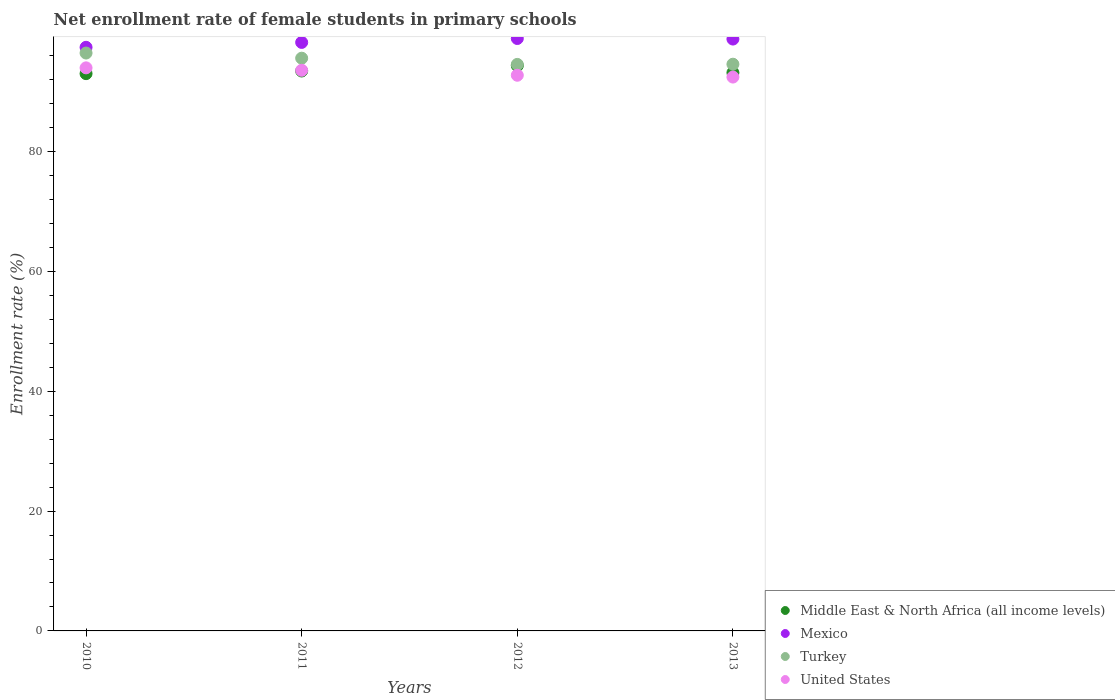What is the net enrollment rate of female students in primary schools in Mexico in 2012?
Offer a terse response. 98.86. Across all years, what is the maximum net enrollment rate of female students in primary schools in Mexico?
Keep it short and to the point. 98.86. Across all years, what is the minimum net enrollment rate of female students in primary schools in Mexico?
Offer a terse response. 97.39. What is the total net enrollment rate of female students in primary schools in United States in the graph?
Make the answer very short. 372.65. What is the difference between the net enrollment rate of female students in primary schools in Turkey in 2010 and that in 2013?
Give a very brief answer. 1.86. What is the difference between the net enrollment rate of female students in primary schools in United States in 2011 and the net enrollment rate of female students in primary schools in Middle East & North Africa (all income levels) in 2013?
Provide a succinct answer. 0.4. What is the average net enrollment rate of female students in primary schools in Turkey per year?
Your response must be concise. 95.27. In the year 2010, what is the difference between the net enrollment rate of female students in primary schools in Turkey and net enrollment rate of female students in primary schools in Middle East & North Africa (all income levels)?
Provide a short and direct response. 3.44. What is the ratio of the net enrollment rate of female students in primary schools in Turkey in 2011 to that in 2013?
Keep it short and to the point. 1.01. Is the net enrollment rate of female students in primary schools in Turkey in 2010 less than that in 2011?
Offer a very short reply. No. What is the difference between the highest and the second highest net enrollment rate of female students in primary schools in Turkey?
Your answer should be compact. 0.86. What is the difference between the highest and the lowest net enrollment rate of female students in primary schools in Turkey?
Offer a very short reply. 1.9. In how many years, is the net enrollment rate of female students in primary schools in Mexico greater than the average net enrollment rate of female students in primary schools in Mexico taken over all years?
Your answer should be compact. 2. Is it the case that in every year, the sum of the net enrollment rate of female students in primary schools in United States and net enrollment rate of female students in primary schools in Turkey  is greater than the sum of net enrollment rate of female students in primary schools in Mexico and net enrollment rate of female students in primary schools in Middle East & North Africa (all income levels)?
Keep it short and to the point. No. Does the net enrollment rate of female students in primary schools in United States monotonically increase over the years?
Ensure brevity in your answer.  No. Is the net enrollment rate of female students in primary schools in Turkey strictly greater than the net enrollment rate of female students in primary schools in United States over the years?
Keep it short and to the point. Yes. Is the net enrollment rate of female students in primary schools in United States strictly less than the net enrollment rate of female students in primary schools in Turkey over the years?
Your answer should be very brief. Yes. What is the title of the graph?
Ensure brevity in your answer.  Net enrollment rate of female students in primary schools. Does "Chile" appear as one of the legend labels in the graph?
Keep it short and to the point. No. What is the label or title of the Y-axis?
Make the answer very short. Enrollment rate (%). What is the Enrollment rate (%) of Middle East & North Africa (all income levels) in 2010?
Your answer should be very brief. 92.99. What is the Enrollment rate (%) of Mexico in 2010?
Provide a short and direct response. 97.39. What is the Enrollment rate (%) of Turkey in 2010?
Your answer should be compact. 96.43. What is the Enrollment rate (%) in United States in 2010?
Provide a succinct answer. 93.96. What is the Enrollment rate (%) in Middle East & North Africa (all income levels) in 2011?
Make the answer very short. 93.43. What is the Enrollment rate (%) in Mexico in 2011?
Your response must be concise. 98.2. What is the Enrollment rate (%) of Turkey in 2011?
Your answer should be compact. 95.57. What is the Enrollment rate (%) of United States in 2011?
Provide a succinct answer. 93.55. What is the Enrollment rate (%) in Middle East & North Africa (all income levels) in 2012?
Keep it short and to the point. 94.33. What is the Enrollment rate (%) in Mexico in 2012?
Make the answer very short. 98.86. What is the Enrollment rate (%) in Turkey in 2012?
Ensure brevity in your answer.  94.53. What is the Enrollment rate (%) of United States in 2012?
Your answer should be compact. 92.72. What is the Enrollment rate (%) of Middle East & North Africa (all income levels) in 2013?
Ensure brevity in your answer.  93.15. What is the Enrollment rate (%) in Mexico in 2013?
Your answer should be compact. 98.76. What is the Enrollment rate (%) of Turkey in 2013?
Offer a very short reply. 94.57. What is the Enrollment rate (%) in United States in 2013?
Give a very brief answer. 92.42. Across all years, what is the maximum Enrollment rate (%) of Middle East & North Africa (all income levels)?
Your response must be concise. 94.33. Across all years, what is the maximum Enrollment rate (%) in Mexico?
Provide a succinct answer. 98.86. Across all years, what is the maximum Enrollment rate (%) in Turkey?
Provide a short and direct response. 96.43. Across all years, what is the maximum Enrollment rate (%) in United States?
Your answer should be compact. 93.96. Across all years, what is the minimum Enrollment rate (%) of Middle East & North Africa (all income levels)?
Your response must be concise. 92.99. Across all years, what is the minimum Enrollment rate (%) of Mexico?
Offer a terse response. 97.39. Across all years, what is the minimum Enrollment rate (%) in Turkey?
Your response must be concise. 94.53. Across all years, what is the minimum Enrollment rate (%) in United States?
Provide a short and direct response. 92.42. What is the total Enrollment rate (%) of Middle East & North Africa (all income levels) in the graph?
Provide a succinct answer. 373.9. What is the total Enrollment rate (%) in Mexico in the graph?
Offer a terse response. 393.2. What is the total Enrollment rate (%) of Turkey in the graph?
Give a very brief answer. 381.1. What is the total Enrollment rate (%) in United States in the graph?
Your answer should be very brief. 372.65. What is the difference between the Enrollment rate (%) of Middle East & North Africa (all income levels) in 2010 and that in 2011?
Make the answer very short. -0.44. What is the difference between the Enrollment rate (%) in Mexico in 2010 and that in 2011?
Your answer should be very brief. -0.82. What is the difference between the Enrollment rate (%) of Turkey in 2010 and that in 2011?
Give a very brief answer. 0.86. What is the difference between the Enrollment rate (%) of United States in 2010 and that in 2011?
Ensure brevity in your answer.  0.41. What is the difference between the Enrollment rate (%) in Middle East & North Africa (all income levels) in 2010 and that in 2012?
Provide a succinct answer. -1.34. What is the difference between the Enrollment rate (%) of Mexico in 2010 and that in 2012?
Give a very brief answer. -1.47. What is the difference between the Enrollment rate (%) in Turkey in 2010 and that in 2012?
Your response must be concise. 1.9. What is the difference between the Enrollment rate (%) of United States in 2010 and that in 2012?
Ensure brevity in your answer.  1.24. What is the difference between the Enrollment rate (%) of Middle East & North Africa (all income levels) in 2010 and that in 2013?
Your response must be concise. -0.16. What is the difference between the Enrollment rate (%) in Mexico in 2010 and that in 2013?
Keep it short and to the point. -1.38. What is the difference between the Enrollment rate (%) of Turkey in 2010 and that in 2013?
Keep it short and to the point. 1.86. What is the difference between the Enrollment rate (%) of United States in 2010 and that in 2013?
Give a very brief answer. 1.54. What is the difference between the Enrollment rate (%) of Middle East & North Africa (all income levels) in 2011 and that in 2012?
Your response must be concise. -0.9. What is the difference between the Enrollment rate (%) of Mexico in 2011 and that in 2012?
Your response must be concise. -0.65. What is the difference between the Enrollment rate (%) in Turkey in 2011 and that in 2012?
Ensure brevity in your answer.  1.04. What is the difference between the Enrollment rate (%) of United States in 2011 and that in 2012?
Your answer should be compact. 0.83. What is the difference between the Enrollment rate (%) in Middle East & North Africa (all income levels) in 2011 and that in 2013?
Give a very brief answer. 0.28. What is the difference between the Enrollment rate (%) in Mexico in 2011 and that in 2013?
Provide a short and direct response. -0.56. What is the difference between the Enrollment rate (%) of United States in 2011 and that in 2013?
Give a very brief answer. 1.13. What is the difference between the Enrollment rate (%) in Middle East & North Africa (all income levels) in 2012 and that in 2013?
Offer a very short reply. 1.18. What is the difference between the Enrollment rate (%) in Mexico in 2012 and that in 2013?
Your answer should be very brief. 0.09. What is the difference between the Enrollment rate (%) in Turkey in 2012 and that in 2013?
Your response must be concise. -0.03. What is the difference between the Enrollment rate (%) of United States in 2012 and that in 2013?
Provide a succinct answer. 0.3. What is the difference between the Enrollment rate (%) in Middle East & North Africa (all income levels) in 2010 and the Enrollment rate (%) in Mexico in 2011?
Offer a terse response. -5.21. What is the difference between the Enrollment rate (%) of Middle East & North Africa (all income levels) in 2010 and the Enrollment rate (%) of Turkey in 2011?
Ensure brevity in your answer.  -2.58. What is the difference between the Enrollment rate (%) in Middle East & North Africa (all income levels) in 2010 and the Enrollment rate (%) in United States in 2011?
Offer a very short reply. -0.56. What is the difference between the Enrollment rate (%) in Mexico in 2010 and the Enrollment rate (%) in Turkey in 2011?
Your response must be concise. 1.82. What is the difference between the Enrollment rate (%) in Mexico in 2010 and the Enrollment rate (%) in United States in 2011?
Keep it short and to the point. 3.84. What is the difference between the Enrollment rate (%) in Turkey in 2010 and the Enrollment rate (%) in United States in 2011?
Provide a short and direct response. 2.88. What is the difference between the Enrollment rate (%) in Middle East & North Africa (all income levels) in 2010 and the Enrollment rate (%) in Mexico in 2012?
Your response must be concise. -5.86. What is the difference between the Enrollment rate (%) of Middle East & North Africa (all income levels) in 2010 and the Enrollment rate (%) of Turkey in 2012?
Ensure brevity in your answer.  -1.54. What is the difference between the Enrollment rate (%) in Middle East & North Africa (all income levels) in 2010 and the Enrollment rate (%) in United States in 2012?
Provide a short and direct response. 0.27. What is the difference between the Enrollment rate (%) of Mexico in 2010 and the Enrollment rate (%) of Turkey in 2012?
Offer a terse response. 2.85. What is the difference between the Enrollment rate (%) of Mexico in 2010 and the Enrollment rate (%) of United States in 2012?
Your answer should be compact. 4.66. What is the difference between the Enrollment rate (%) in Turkey in 2010 and the Enrollment rate (%) in United States in 2012?
Your answer should be very brief. 3.71. What is the difference between the Enrollment rate (%) in Middle East & North Africa (all income levels) in 2010 and the Enrollment rate (%) in Mexico in 2013?
Your response must be concise. -5.77. What is the difference between the Enrollment rate (%) in Middle East & North Africa (all income levels) in 2010 and the Enrollment rate (%) in Turkey in 2013?
Provide a short and direct response. -1.58. What is the difference between the Enrollment rate (%) of Middle East & North Africa (all income levels) in 2010 and the Enrollment rate (%) of United States in 2013?
Give a very brief answer. 0.57. What is the difference between the Enrollment rate (%) in Mexico in 2010 and the Enrollment rate (%) in Turkey in 2013?
Provide a succinct answer. 2.82. What is the difference between the Enrollment rate (%) in Mexico in 2010 and the Enrollment rate (%) in United States in 2013?
Offer a very short reply. 4.97. What is the difference between the Enrollment rate (%) in Turkey in 2010 and the Enrollment rate (%) in United States in 2013?
Make the answer very short. 4.01. What is the difference between the Enrollment rate (%) of Middle East & North Africa (all income levels) in 2011 and the Enrollment rate (%) of Mexico in 2012?
Your answer should be very brief. -5.43. What is the difference between the Enrollment rate (%) of Middle East & North Africa (all income levels) in 2011 and the Enrollment rate (%) of Turkey in 2012?
Your response must be concise. -1.1. What is the difference between the Enrollment rate (%) in Middle East & North Africa (all income levels) in 2011 and the Enrollment rate (%) in United States in 2012?
Ensure brevity in your answer.  0.71. What is the difference between the Enrollment rate (%) of Mexico in 2011 and the Enrollment rate (%) of Turkey in 2012?
Provide a short and direct response. 3.67. What is the difference between the Enrollment rate (%) in Mexico in 2011 and the Enrollment rate (%) in United States in 2012?
Make the answer very short. 5.48. What is the difference between the Enrollment rate (%) of Turkey in 2011 and the Enrollment rate (%) of United States in 2012?
Keep it short and to the point. 2.85. What is the difference between the Enrollment rate (%) of Middle East & North Africa (all income levels) in 2011 and the Enrollment rate (%) of Mexico in 2013?
Your answer should be very brief. -5.33. What is the difference between the Enrollment rate (%) of Middle East & North Africa (all income levels) in 2011 and the Enrollment rate (%) of Turkey in 2013?
Your response must be concise. -1.14. What is the difference between the Enrollment rate (%) in Middle East & North Africa (all income levels) in 2011 and the Enrollment rate (%) in United States in 2013?
Your response must be concise. 1.01. What is the difference between the Enrollment rate (%) of Mexico in 2011 and the Enrollment rate (%) of Turkey in 2013?
Offer a very short reply. 3.64. What is the difference between the Enrollment rate (%) in Mexico in 2011 and the Enrollment rate (%) in United States in 2013?
Your answer should be very brief. 5.78. What is the difference between the Enrollment rate (%) in Turkey in 2011 and the Enrollment rate (%) in United States in 2013?
Offer a very short reply. 3.15. What is the difference between the Enrollment rate (%) of Middle East & North Africa (all income levels) in 2012 and the Enrollment rate (%) of Mexico in 2013?
Offer a very short reply. -4.43. What is the difference between the Enrollment rate (%) in Middle East & North Africa (all income levels) in 2012 and the Enrollment rate (%) in Turkey in 2013?
Keep it short and to the point. -0.24. What is the difference between the Enrollment rate (%) in Middle East & North Africa (all income levels) in 2012 and the Enrollment rate (%) in United States in 2013?
Provide a short and direct response. 1.91. What is the difference between the Enrollment rate (%) of Mexico in 2012 and the Enrollment rate (%) of Turkey in 2013?
Your answer should be very brief. 4.29. What is the difference between the Enrollment rate (%) in Mexico in 2012 and the Enrollment rate (%) in United States in 2013?
Keep it short and to the point. 6.44. What is the difference between the Enrollment rate (%) in Turkey in 2012 and the Enrollment rate (%) in United States in 2013?
Provide a succinct answer. 2.11. What is the average Enrollment rate (%) in Middle East & North Africa (all income levels) per year?
Your response must be concise. 93.47. What is the average Enrollment rate (%) of Mexico per year?
Provide a short and direct response. 98.3. What is the average Enrollment rate (%) in Turkey per year?
Keep it short and to the point. 95.27. What is the average Enrollment rate (%) in United States per year?
Provide a succinct answer. 93.16. In the year 2010, what is the difference between the Enrollment rate (%) in Middle East & North Africa (all income levels) and Enrollment rate (%) in Mexico?
Ensure brevity in your answer.  -4.39. In the year 2010, what is the difference between the Enrollment rate (%) in Middle East & North Africa (all income levels) and Enrollment rate (%) in Turkey?
Offer a very short reply. -3.44. In the year 2010, what is the difference between the Enrollment rate (%) of Middle East & North Africa (all income levels) and Enrollment rate (%) of United States?
Offer a very short reply. -0.97. In the year 2010, what is the difference between the Enrollment rate (%) in Mexico and Enrollment rate (%) in Turkey?
Offer a very short reply. 0.95. In the year 2010, what is the difference between the Enrollment rate (%) in Mexico and Enrollment rate (%) in United States?
Make the answer very short. 3.43. In the year 2010, what is the difference between the Enrollment rate (%) in Turkey and Enrollment rate (%) in United States?
Offer a very short reply. 2.47. In the year 2011, what is the difference between the Enrollment rate (%) of Middle East & North Africa (all income levels) and Enrollment rate (%) of Mexico?
Offer a terse response. -4.77. In the year 2011, what is the difference between the Enrollment rate (%) in Middle East & North Africa (all income levels) and Enrollment rate (%) in Turkey?
Provide a succinct answer. -2.14. In the year 2011, what is the difference between the Enrollment rate (%) in Middle East & North Africa (all income levels) and Enrollment rate (%) in United States?
Offer a terse response. -0.12. In the year 2011, what is the difference between the Enrollment rate (%) of Mexico and Enrollment rate (%) of Turkey?
Your answer should be compact. 2.63. In the year 2011, what is the difference between the Enrollment rate (%) of Mexico and Enrollment rate (%) of United States?
Ensure brevity in your answer.  4.65. In the year 2011, what is the difference between the Enrollment rate (%) in Turkey and Enrollment rate (%) in United States?
Offer a terse response. 2.02. In the year 2012, what is the difference between the Enrollment rate (%) in Middle East & North Africa (all income levels) and Enrollment rate (%) in Mexico?
Give a very brief answer. -4.52. In the year 2012, what is the difference between the Enrollment rate (%) in Middle East & North Africa (all income levels) and Enrollment rate (%) in Turkey?
Provide a succinct answer. -0.2. In the year 2012, what is the difference between the Enrollment rate (%) in Middle East & North Africa (all income levels) and Enrollment rate (%) in United States?
Provide a short and direct response. 1.61. In the year 2012, what is the difference between the Enrollment rate (%) of Mexico and Enrollment rate (%) of Turkey?
Ensure brevity in your answer.  4.32. In the year 2012, what is the difference between the Enrollment rate (%) in Mexico and Enrollment rate (%) in United States?
Offer a terse response. 6.13. In the year 2012, what is the difference between the Enrollment rate (%) of Turkey and Enrollment rate (%) of United States?
Provide a succinct answer. 1.81. In the year 2013, what is the difference between the Enrollment rate (%) of Middle East & North Africa (all income levels) and Enrollment rate (%) of Mexico?
Give a very brief answer. -5.61. In the year 2013, what is the difference between the Enrollment rate (%) of Middle East & North Africa (all income levels) and Enrollment rate (%) of Turkey?
Give a very brief answer. -1.42. In the year 2013, what is the difference between the Enrollment rate (%) in Middle East & North Africa (all income levels) and Enrollment rate (%) in United States?
Your answer should be compact. 0.73. In the year 2013, what is the difference between the Enrollment rate (%) of Mexico and Enrollment rate (%) of Turkey?
Offer a terse response. 4.19. In the year 2013, what is the difference between the Enrollment rate (%) in Mexico and Enrollment rate (%) in United States?
Keep it short and to the point. 6.34. In the year 2013, what is the difference between the Enrollment rate (%) of Turkey and Enrollment rate (%) of United States?
Your answer should be compact. 2.15. What is the ratio of the Enrollment rate (%) in Middle East & North Africa (all income levels) in 2010 to that in 2011?
Make the answer very short. 1. What is the ratio of the Enrollment rate (%) in Mexico in 2010 to that in 2011?
Provide a short and direct response. 0.99. What is the ratio of the Enrollment rate (%) of Turkey in 2010 to that in 2011?
Keep it short and to the point. 1.01. What is the ratio of the Enrollment rate (%) in United States in 2010 to that in 2011?
Offer a terse response. 1. What is the ratio of the Enrollment rate (%) of Middle East & North Africa (all income levels) in 2010 to that in 2012?
Keep it short and to the point. 0.99. What is the ratio of the Enrollment rate (%) in Mexico in 2010 to that in 2012?
Ensure brevity in your answer.  0.99. What is the ratio of the Enrollment rate (%) in Turkey in 2010 to that in 2012?
Provide a short and direct response. 1.02. What is the ratio of the Enrollment rate (%) in United States in 2010 to that in 2012?
Offer a very short reply. 1.01. What is the ratio of the Enrollment rate (%) of Mexico in 2010 to that in 2013?
Keep it short and to the point. 0.99. What is the ratio of the Enrollment rate (%) of Turkey in 2010 to that in 2013?
Provide a short and direct response. 1.02. What is the ratio of the Enrollment rate (%) in United States in 2010 to that in 2013?
Provide a short and direct response. 1.02. What is the ratio of the Enrollment rate (%) of United States in 2011 to that in 2012?
Offer a very short reply. 1.01. What is the ratio of the Enrollment rate (%) of Middle East & North Africa (all income levels) in 2011 to that in 2013?
Provide a short and direct response. 1. What is the ratio of the Enrollment rate (%) in Mexico in 2011 to that in 2013?
Your response must be concise. 0.99. What is the ratio of the Enrollment rate (%) in Turkey in 2011 to that in 2013?
Provide a succinct answer. 1.01. What is the ratio of the Enrollment rate (%) in United States in 2011 to that in 2013?
Provide a short and direct response. 1.01. What is the ratio of the Enrollment rate (%) of Middle East & North Africa (all income levels) in 2012 to that in 2013?
Ensure brevity in your answer.  1.01. What is the ratio of the Enrollment rate (%) of Mexico in 2012 to that in 2013?
Offer a very short reply. 1. What is the ratio of the Enrollment rate (%) in Turkey in 2012 to that in 2013?
Offer a terse response. 1. What is the ratio of the Enrollment rate (%) in United States in 2012 to that in 2013?
Offer a terse response. 1. What is the difference between the highest and the second highest Enrollment rate (%) in Middle East & North Africa (all income levels)?
Provide a short and direct response. 0.9. What is the difference between the highest and the second highest Enrollment rate (%) of Mexico?
Your response must be concise. 0.09. What is the difference between the highest and the second highest Enrollment rate (%) in Turkey?
Give a very brief answer. 0.86. What is the difference between the highest and the second highest Enrollment rate (%) in United States?
Your answer should be very brief. 0.41. What is the difference between the highest and the lowest Enrollment rate (%) of Middle East & North Africa (all income levels)?
Your answer should be compact. 1.34. What is the difference between the highest and the lowest Enrollment rate (%) in Mexico?
Your answer should be very brief. 1.47. What is the difference between the highest and the lowest Enrollment rate (%) in Turkey?
Keep it short and to the point. 1.9. What is the difference between the highest and the lowest Enrollment rate (%) of United States?
Make the answer very short. 1.54. 